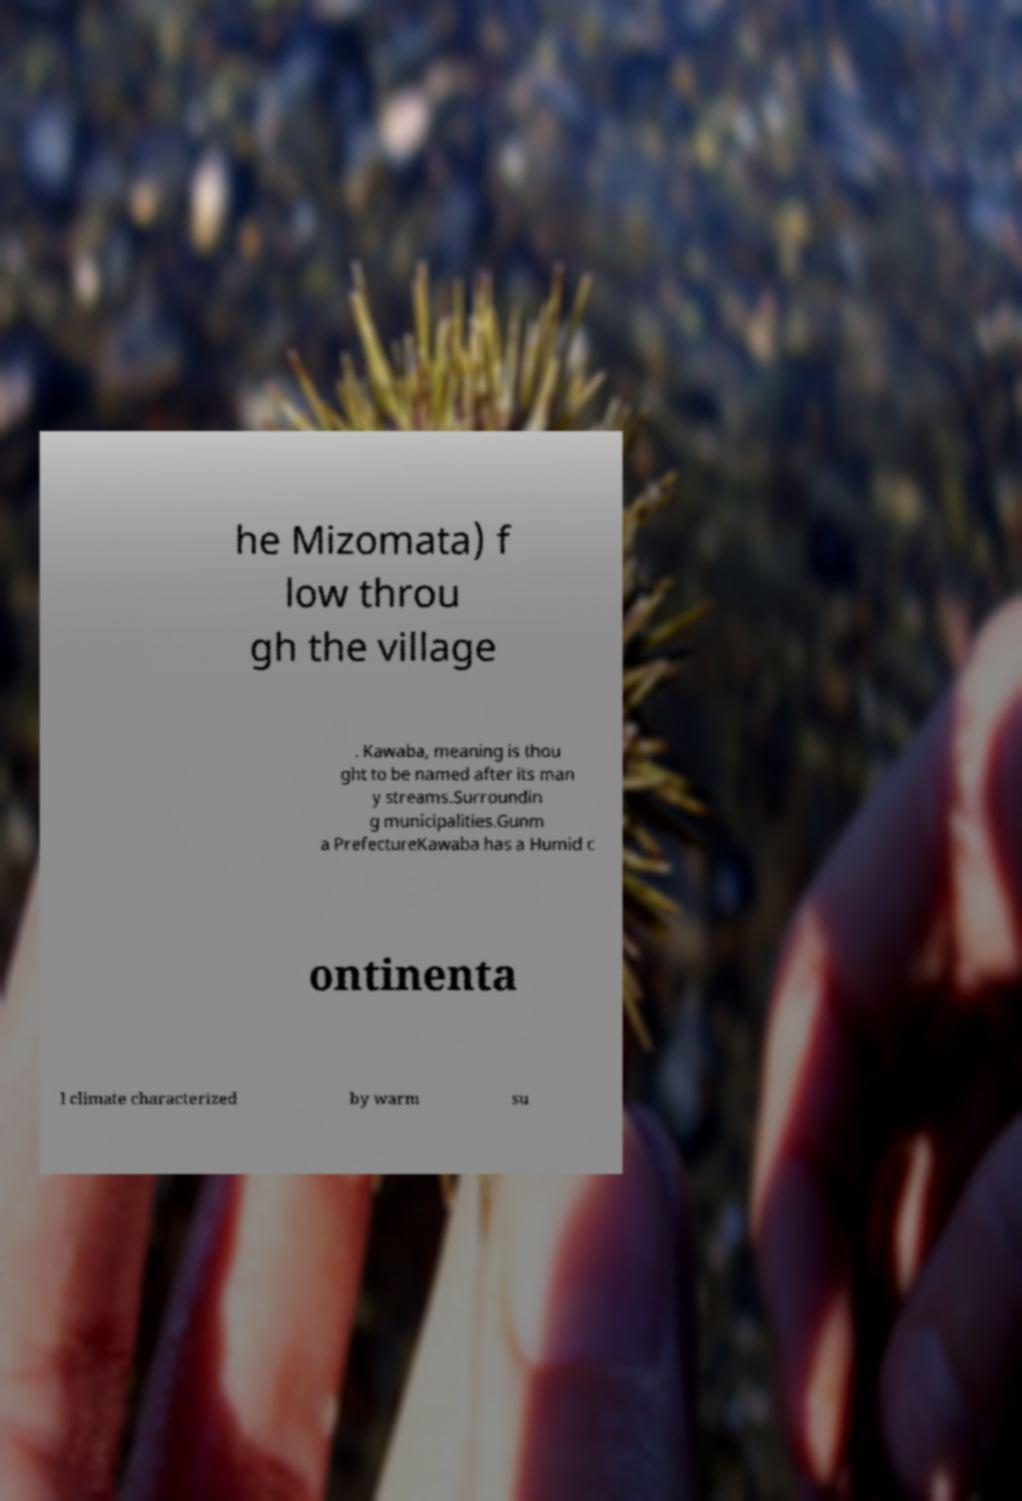I need the written content from this picture converted into text. Can you do that? he Mizomata) f low throu gh the village . Kawaba, meaning is thou ght to be named after its man y streams.Surroundin g municipalities.Gunm a PrefectureKawaba has a Humid c ontinenta l climate characterized by warm su 